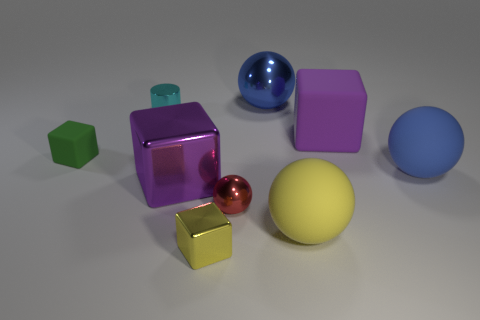Subtract all blue spheres. How many were subtracted if there are1blue spheres left? 1 Subtract all yellow cubes. How many cubes are left? 3 Subtract all yellow spheres. How many spheres are left? 3 Subtract all purple cubes. How many blue balls are left? 2 Add 1 small yellow things. How many objects exist? 10 Subtract all balls. How many objects are left? 5 Subtract 1 cylinders. How many cylinders are left? 0 Subtract all cyan metal objects. Subtract all tiny spheres. How many objects are left? 7 Add 8 rubber spheres. How many rubber spheres are left? 10 Add 7 gray rubber cubes. How many gray rubber cubes exist? 7 